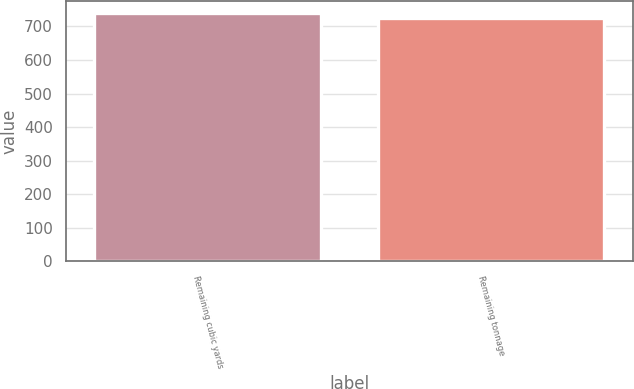<chart> <loc_0><loc_0><loc_500><loc_500><bar_chart><fcel>Remaining cubic yards<fcel>Remaining tonnage<nl><fcel>739<fcel>726<nl></chart> 